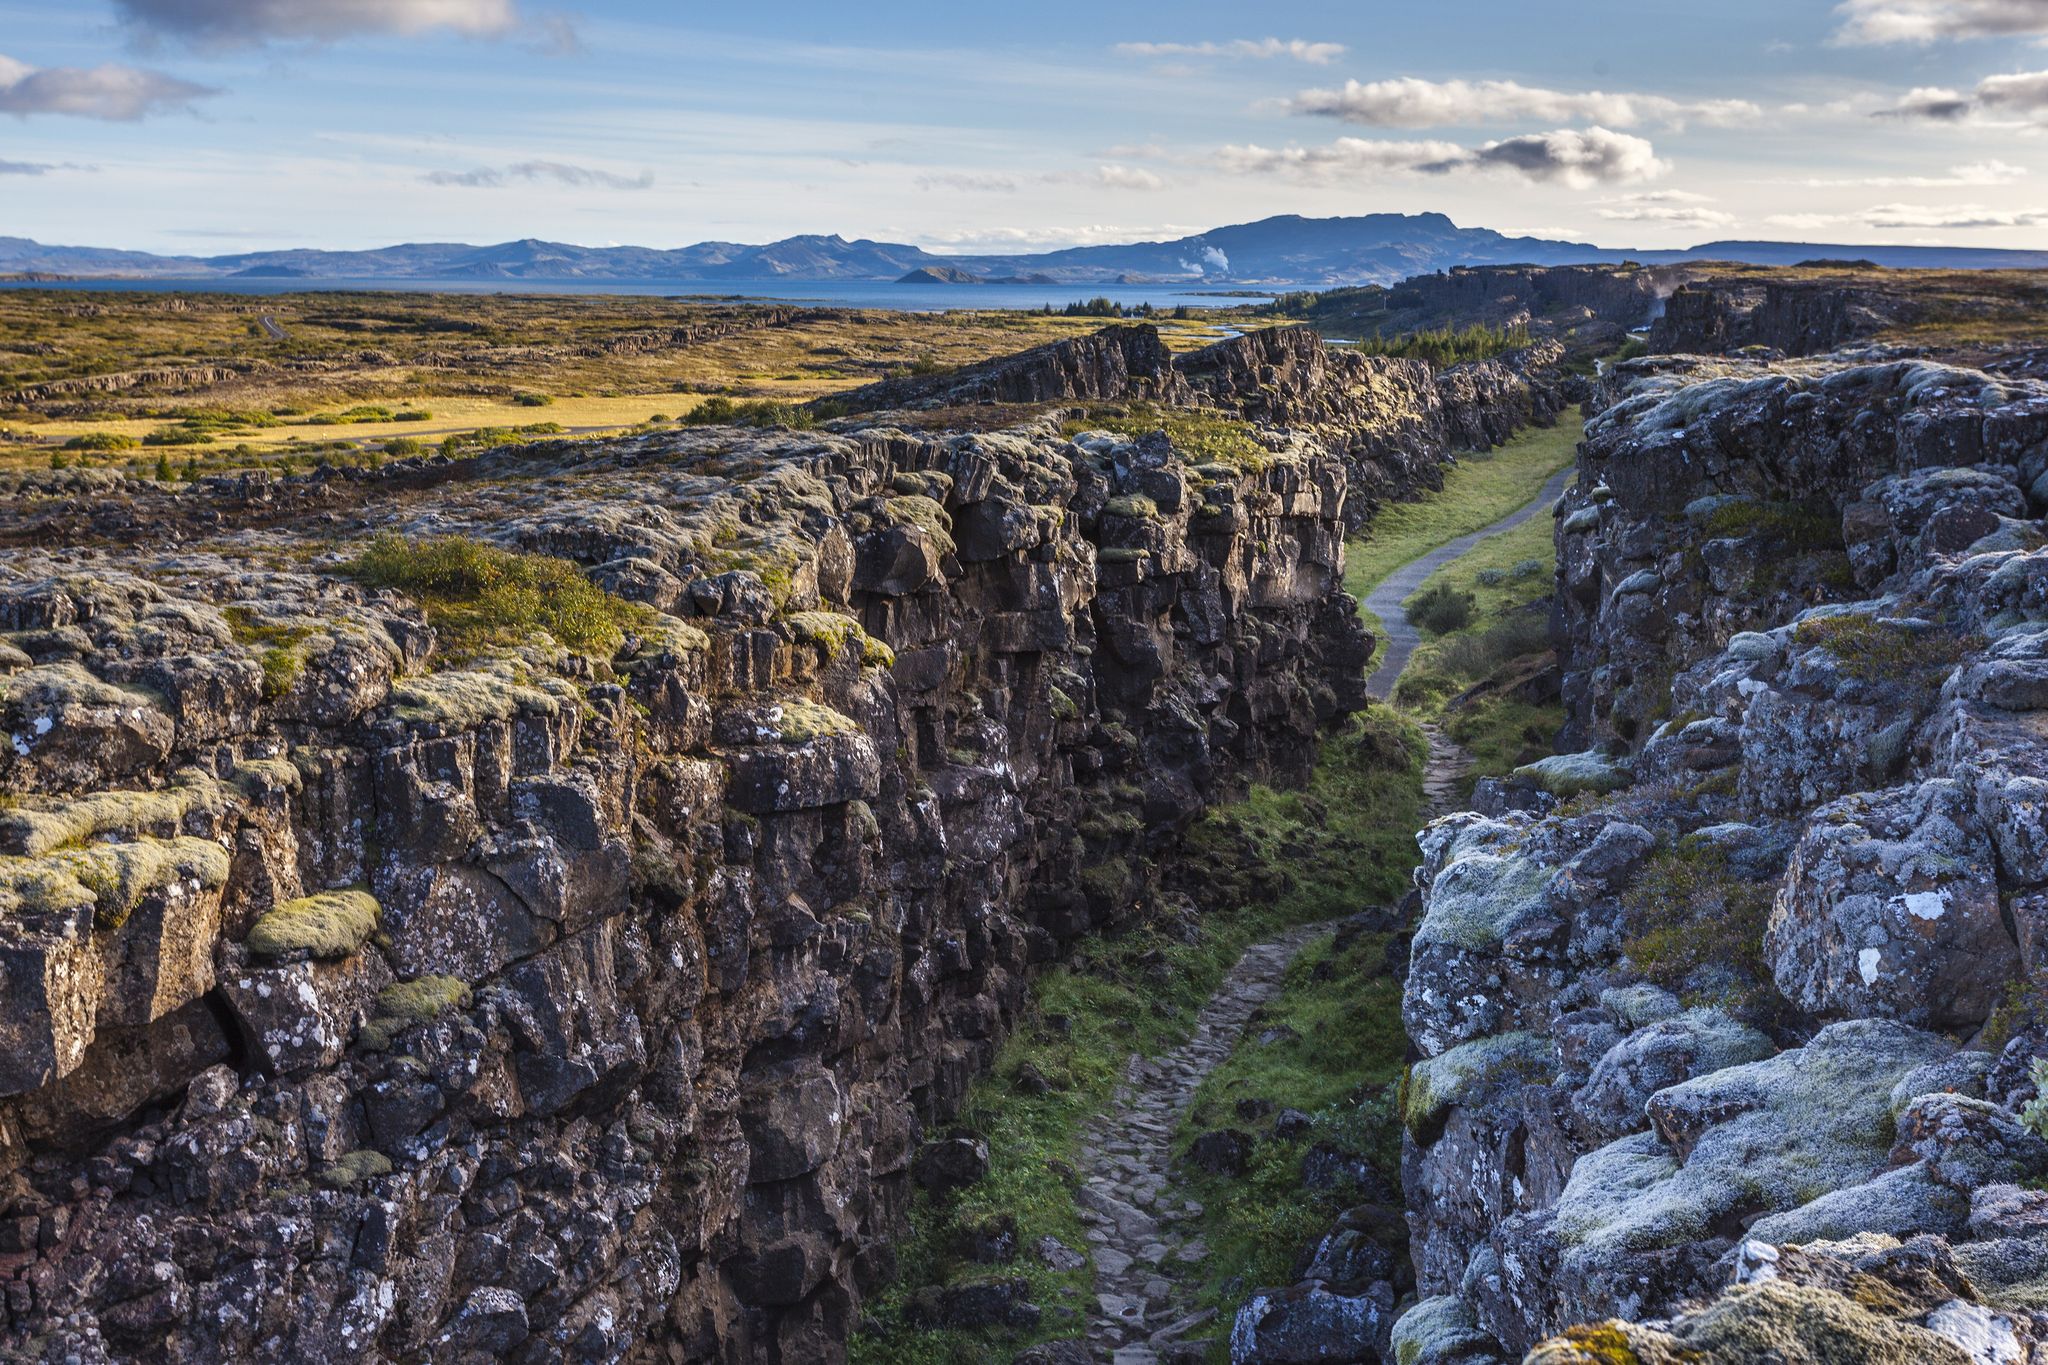What can you tell about the historical significance of Þingvellir National Park? Þingvellir National Park holds deep historical significance for Iceland. It is the site where the Alþingi, one of the world's oldest parliaments, was established in 930 AD. This location was chosen for its central location and natural amphitheater qualities, making it an ideal gathering place for chieftains from different regions of Iceland. Annual assemblies were held here, where laws were made, disputes settled, and decisions on matters of national importance were taken. The landscape, with its dramatic geological formations, added to the solemn and majestic atmosphere of these historic gatherings. 